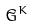Convert formula to latex. <formula><loc_0><loc_0><loc_500><loc_500>\tilde { G } ^ { K }</formula> 